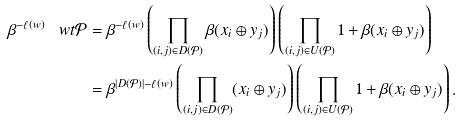<formula> <loc_0><loc_0><loc_500><loc_500>\beta ^ { - \ell ( w ) } \, \ w t { \mathcal { P } } & = \beta ^ { - \ell ( w ) } \left ( \prod _ { ( i , j ) \in D ( \mathcal { P } ) } \beta ( x _ { i } \oplus y _ { j } ) \right ) \left ( \prod _ { ( i , j ) \in U ( \mathcal { P } ) } 1 + \beta ( x _ { i } \oplus y _ { j } ) \right ) \\ & = \beta ^ { | D ( \mathcal { P } ) | - \ell ( w ) } \left ( \prod _ { ( i , j ) \in D ( \mathcal { P } ) } ( x _ { i } \oplus y _ { j } ) \right ) \left ( \prod _ { ( i , j ) \in U ( \mathcal { P } ) } 1 + \beta ( x _ { i } \oplus y _ { j } ) \right ) .</formula> 